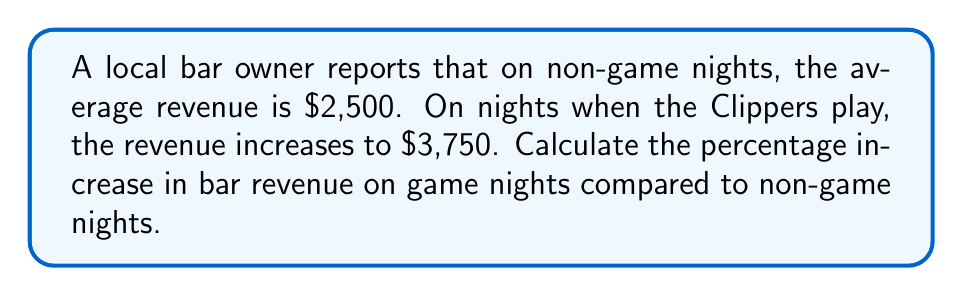Can you solve this math problem? To calculate the percentage increase, we'll follow these steps:

1. Calculate the difference in revenue:
   $\text{Difference} = \text{Game night revenue} - \text{Non-game night revenue}$
   $\text{Difference} = \$3,750 - \$2,500 = \$1,250$

2. Divide the difference by the original (non-game night) revenue:
   $\text{Fractional increase} = \frac{\text{Difference}}{\text{Non-game night revenue}}$
   $\text{Fractional increase} = \frac{\$1,250}{\$2,500} = 0.5$

3. Convert the fractional increase to a percentage by multiplying by 100:
   $\text{Percentage increase} = \text{Fractional increase} \times 100\%$
   $\text{Percentage increase} = 0.5 \times 100\% = 50\%$

Therefore, the bar's revenue increases by 50% on game nights compared to non-game nights.
Answer: 50% 